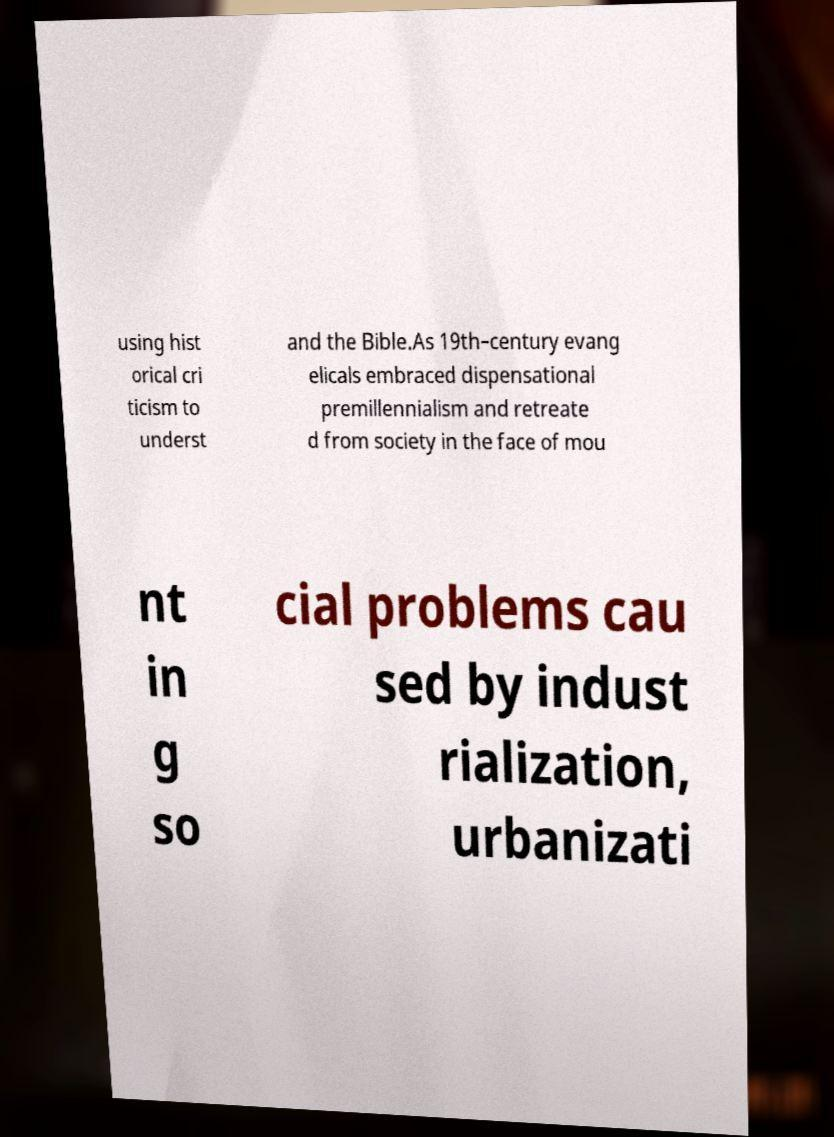I need the written content from this picture converted into text. Can you do that? using hist orical cri ticism to underst and the Bible.As 19th–century evang elicals embraced dispensational premillennialism and retreate d from society in the face of mou nt in g so cial problems cau sed by indust rialization, urbanizati 